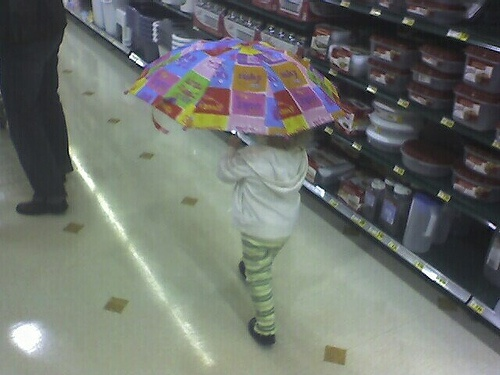Describe the objects in this image and their specific colors. I can see umbrella in black, gray, and purple tones, people in black, gray, and darkgray tones, people in black, darkgray, and gray tones, bowl in black and gray tones, and bottle in black and gray tones in this image. 